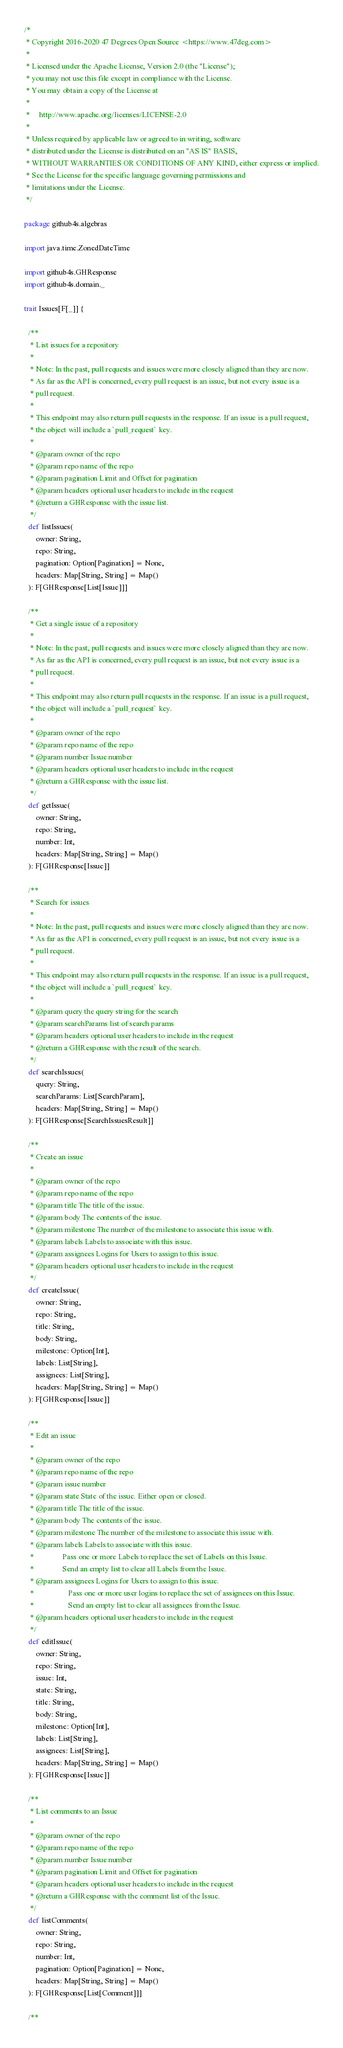<code> <loc_0><loc_0><loc_500><loc_500><_Scala_>/*
 * Copyright 2016-2020 47 Degrees Open Source <https://www.47deg.com>
 *
 * Licensed under the Apache License, Version 2.0 (the "License");
 * you may not use this file except in compliance with the License.
 * You may obtain a copy of the License at
 *
 *     http://www.apache.org/licenses/LICENSE-2.0
 *
 * Unless required by applicable law or agreed to in writing, software
 * distributed under the License is distributed on an "AS IS" BASIS,
 * WITHOUT WARRANTIES OR CONDITIONS OF ANY KIND, either express or implied.
 * See the License for the specific language governing permissions and
 * limitations under the License.
 */

package github4s.algebras

import java.time.ZonedDateTime

import github4s.GHResponse
import github4s.domain._

trait Issues[F[_]] {

  /**
   * List issues for a repository
   *
   * Note: In the past, pull requests and issues were more closely aligned than they are now.
   * As far as the API is concerned, every pull request is an issue, but not every issue is a
   * pull request.
   *
   * This endpoint may also return pull requests in the response. If an issue is a pull request,
   * the object will include a `pull_request` key.
   *
   * @param owner of the repo
   * @param repo name of the repo
   * @param pagination Limit and Offset for pagination
   * @param headers optional user headers to include in the request
   * @return a GHResponse with the issue list.
   */
  def listIssues(
      owner: String,
      repo: String,
      pagination: Option[Pagination] = None,
      headers: Map[String, String] = Map()
  ): F[GHResponse[List[Issue]]]

  /**
   * Get a single issue of a repository
   *
   * Note: In the past, pull requests and issues were more closely aligned than they are now.
   * As far as the API is concerned, every pull request is an issue, but not every issue is a
   * pull request.
   *
   * This endpoint may also return pull requests in the response. If an issue is a pull request,
   * the object will include a `pull_request` key.
   *
   * @param owner of the repo
   * @param repo name of the repo
   * @param number Issue number
   * @param headers optional user headers to include in the request
   * @return a GHResponse with the issue list.
   */
  def getIssue(
      owner: String,
      repo: String,
      number: Int,
      headers: Map[String, String] = Map()
  ): F[GHResponse[Issue]]

  /**
   * Search for issues
   *
   * Note: In the past, pull requests and issues were more closely aligned than they are now.
   * As far as the API is concerned, every pull request is an issue, but not every issue is a
   * pull request.
   *
   * This endpoint may also return pull requests in the response. If an issue is a pull request,
   * the object will include a `pull_request` key.
   *
   * @param query the query string for the search
   * @param searchParams list of search params
   * @param headers optional user headers to include in the request
   * @return a GHResponse with the result of the search.
   */
  def searchIssues(
      query: String,
      searchParams: List[SearchParam],
      headers: Map[String, String] = Map()
  ): F[GHResponse[SearchIssuesResult]]

  /**
   * Create an issue
   *
   * @param owner of the repo
   * @param repo name of the repo
   * @param title The title of the issue.
   * @param body The contents of the issue.
   * @param milestone The number of the milestone to associate this issue with.
   * @param labels Labels to associate with this issue.
   * @param assignees Logins for Users to assign to this issue.
   * @param headers optional user headers to include in the request
   */
  def createIssue(
      owner: String,
      repo: String,
      title: String,
      body: String,
      milestone: Option[Int],
      labels: List[String],
      assignees: List[String],
      headers: Map[String, String] = Map()
  ): F[GHResponse[Issue]]

  /**
   * Edit an issue
   *
   * @param owner of the repo
   * @param repo name of the repo
   * @param issue number
   * @param state State of the issue. Either open or closed.
   * @param title The title of the issue.
   * @param body The contents of the issue.
   * @param milestone The number of the milestone to associate this issue with.
   * @param labels Labels to associate with this issue.
   *               Pass one or more Labels to replace the set of Labels on this Issue.
   *               Send an empty list to clear all Labels from the Issue.
   * @param assignees Logins for Users to assign to this issue.
   *                  Pass one or more user logins to replace the set of assignees on this Issue.
   *                  Send an empty list to clear all assignees from the Issue.
   * @param headers optional user headers to include in the request
   */
  def editIssue(
      owner: String,
      repo: String,
      issue: Int,
      state: String,
      title: String,
      body: String,
      milestone: Option[Int],
      labels: List[String],
      assignees: List[String],
      headers: Map[String, String] = Map()
  ): F[GHResponse[Issue]]

  /**
   * List comments to an Issue
   *
   * @param owner of the repo
   * @param repo name of the repo
   * @param number Issue number
   * @param pagination Limit and Offset for pagination
   * @param headers optional user headers to include in the request
   * @return a GHResponse with the comment list of the Issue.
   */
  def listComments(
      owner: String,
      repo: String,
      number: Int,
      pagination: Option[Pagination] = None,
      headers: Map[String, String] = Map()
  ): F[GHResponse[List[Comment]]]

  /**</code> 